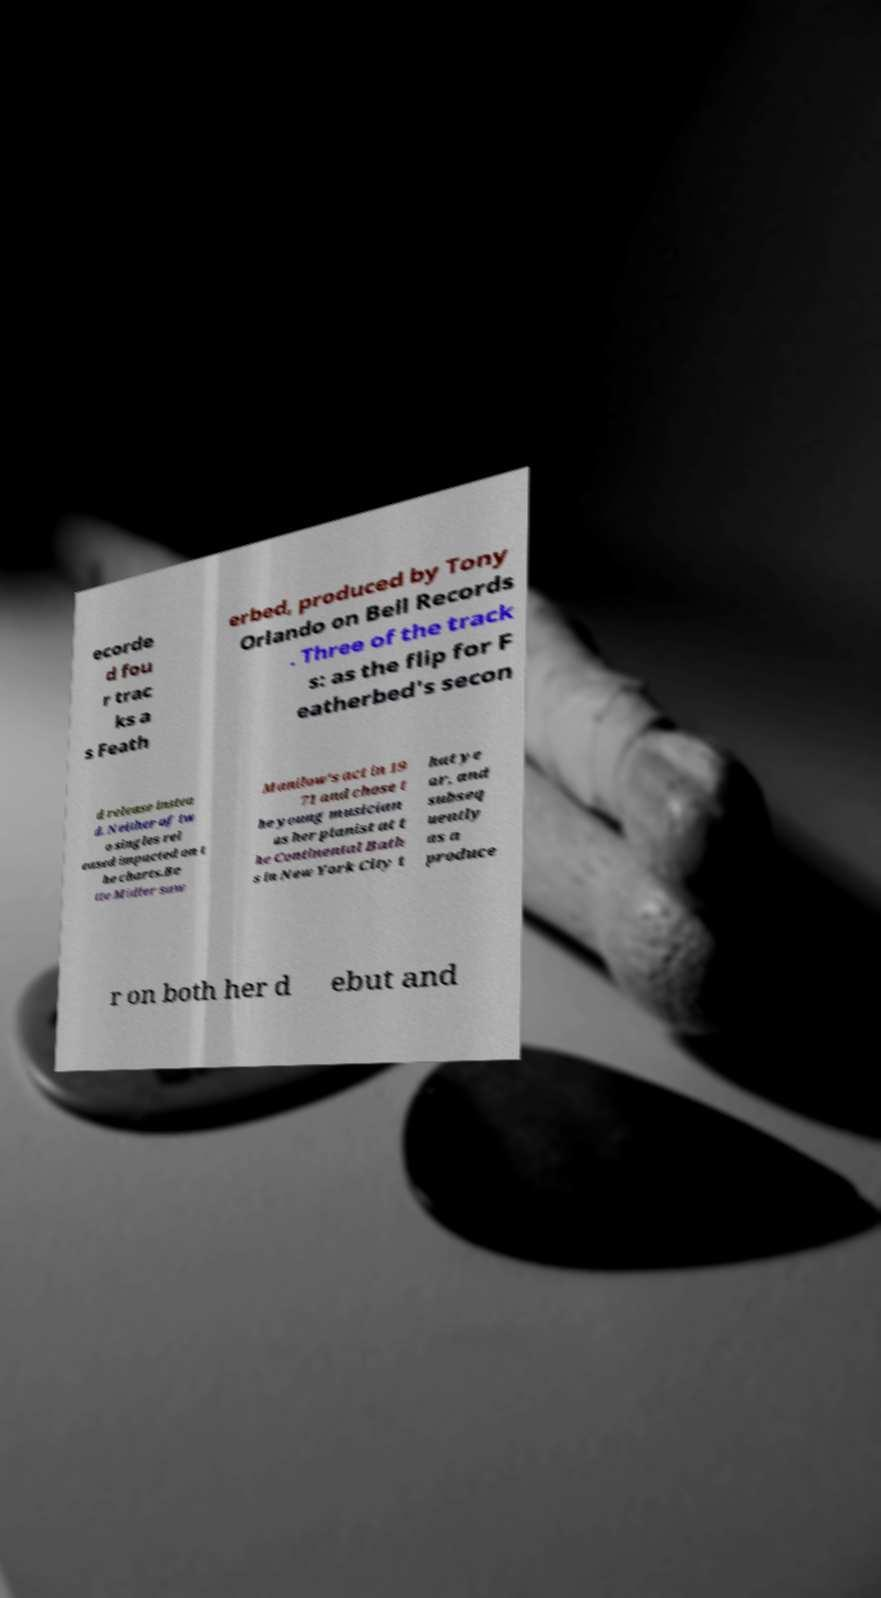Could you extract and type out the text from this image? ecorde d fou r trac ks a s Feath erbed, produced by Tony Orlando on Bell Records . Three of the track s: as the flip for F eatherbed's secon d release instea d. Neither of tw o singles rel eased impacted on t he charts.Be tte Midler saw Manilow's act in 19 71 and chose t he young musician as her pianist at t he Continental Bath s in New York City t hat ye ar, and subseq uently as a produce r on both her d ebut and 